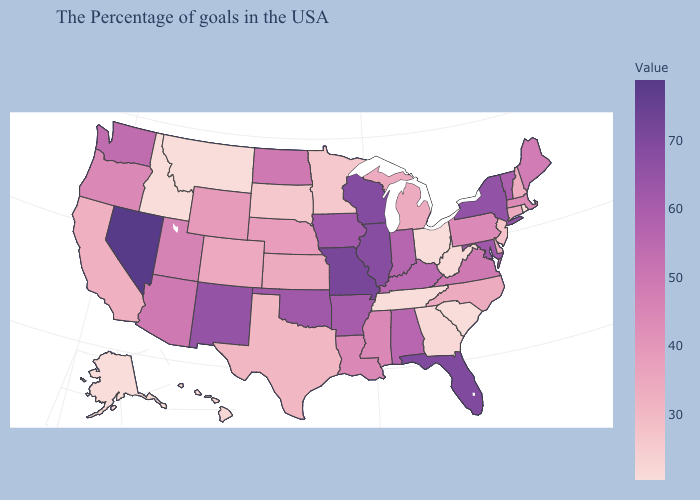Does Kansas have the highest value in the USA?
Give a very brief answer. No. Among the states that border Arkansas , which have the lowest value?
Give a very brief answer. Tennessee. Among the states that border Montana , which have the lowest value?
Write a very short answer. Idaho. 